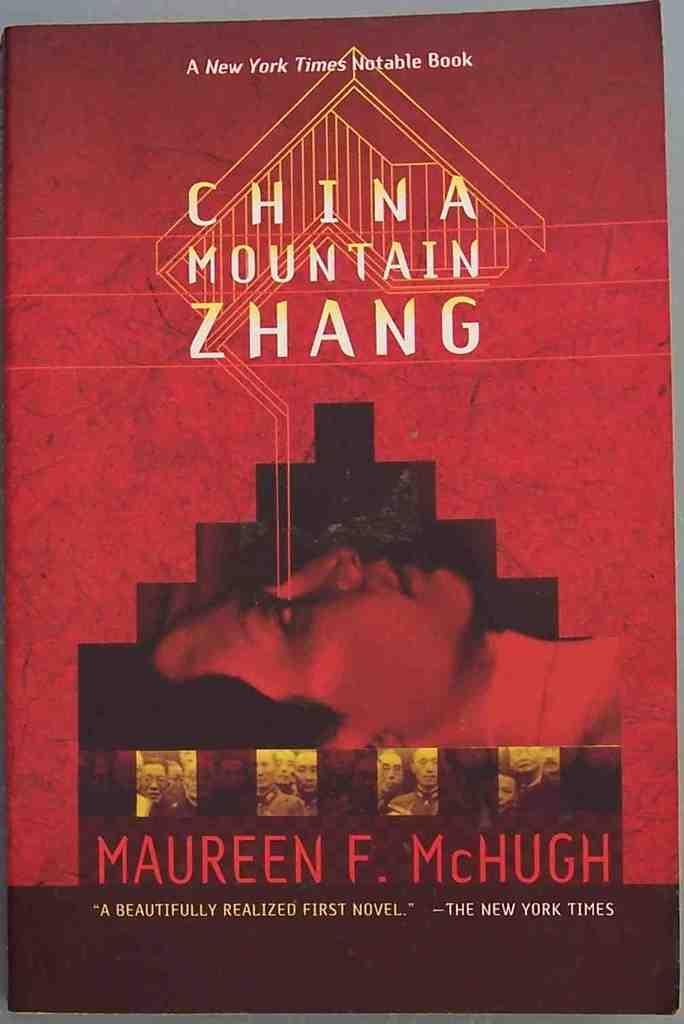Provide a one-sentence caption for the provided image. A novel entitled "China Mountain Zhang" by Maureen F. McHugh. 